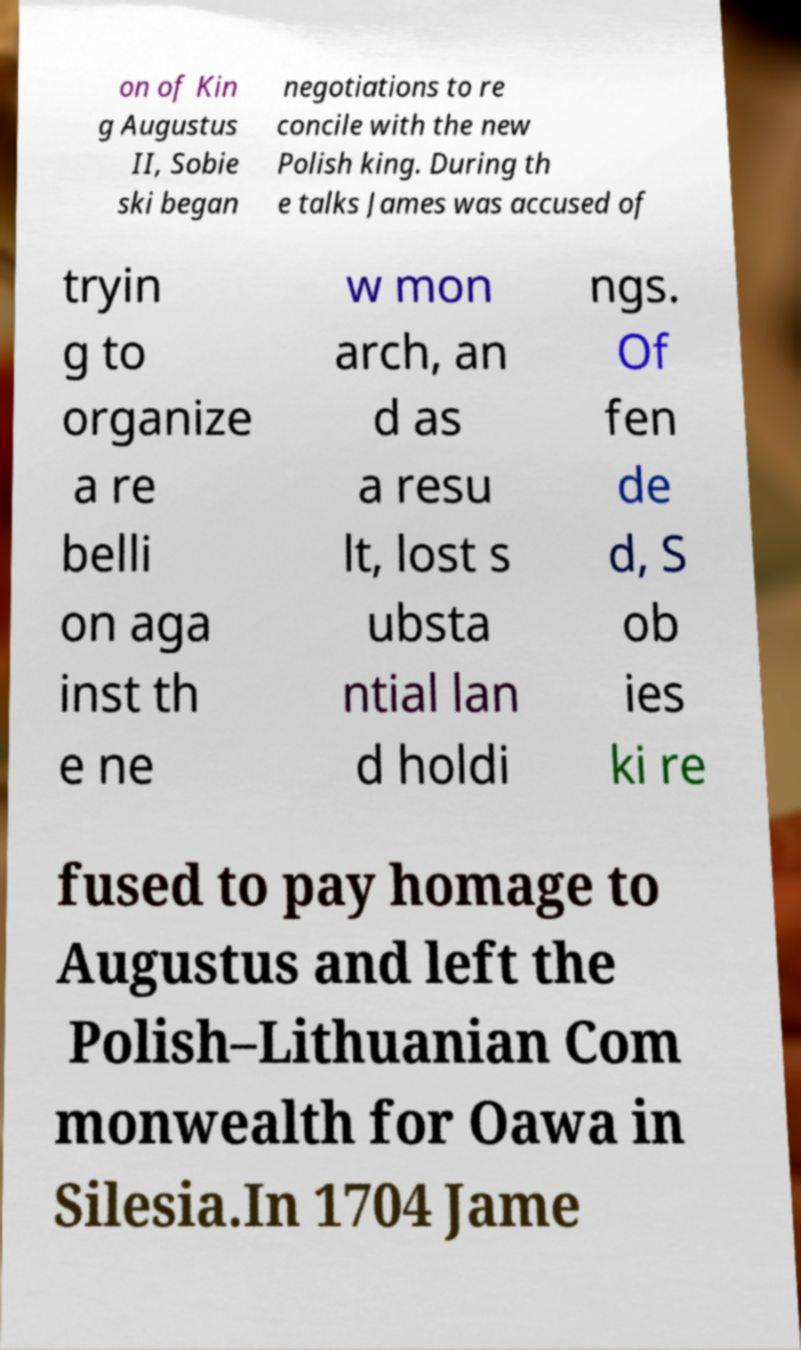There's text embedded in this image that I need extracted. Can you transcribe it verbatim? on of Kin g Augustus II, Sobie ski began negotiations to re concile with the new Polish king. During th e talks James was accused of tryin g to organize a re belli on aga inst th e ne w mon arch, an d as a resu lt, lost s ubsta ntial lan d holdi ngs. Of fen de d, S ob ies ki re fused to pay homage to Augustus and left the Polish–Lithuanian Com monwealth for Oawa in Silesia.In 1704 Jame 